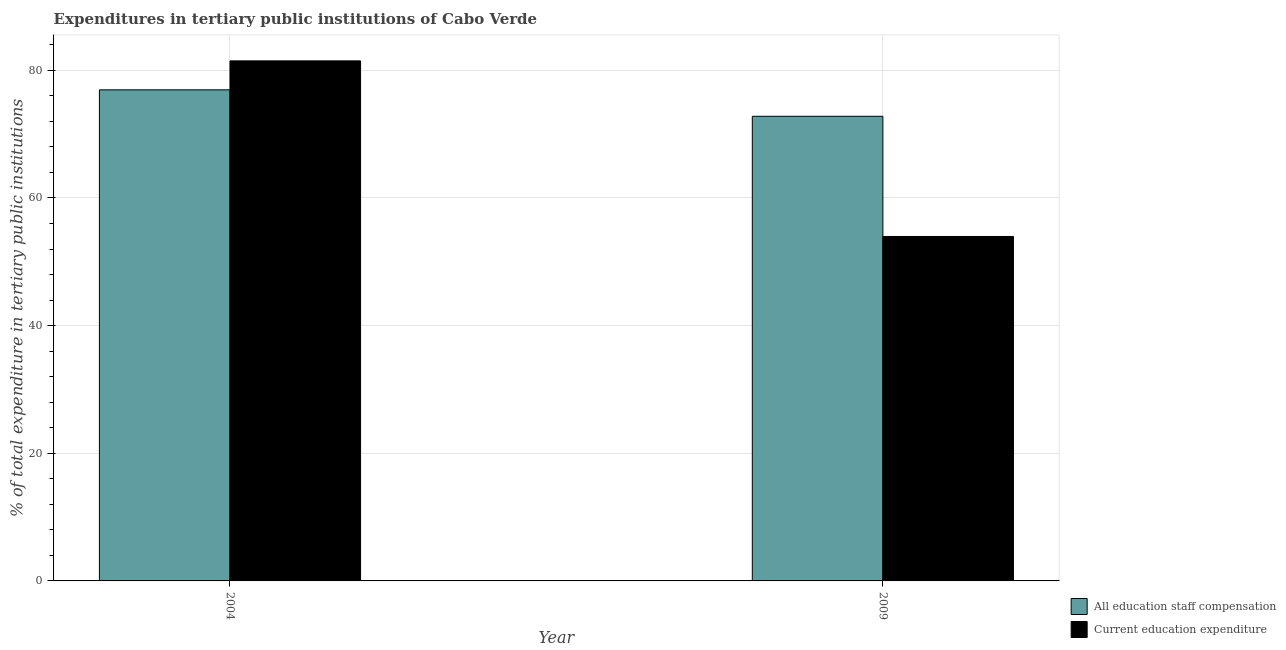What is the label of the 2nd group of bars from the left?
Provide a short and direct response. 2009. In how many cases, is the number of bars for a given year not equal to the number of legend labels?
Ensure brevity in your answer.  0. What is the expenditure in education in 2004?
Offer a very short reply. 81.48. Across all years, what is the maximum expenditure in staff compensation?
Your response must be concise. 76.94. Across all years, what is the minimum expenditure in staff compensation?
Offer a terse response. 72.8. What is the total expenditure in staff compensation in the graph?
Keep it short and to the point. 149.73. What is the difference between the expenditure in staff compensation in 2004 and that in 2009?
Offer a terse response. 4.14. What is the difference between the expenditure in staff compensation in 2004 and the expenditure in education in 2009?
Make the answer very short. 4.14. What is the average expenditure in education per year?
Offer a terse response. 67.72. In how many years, is the expenditure in education greater than 60 %?
Your answer should be compact. 1. What is the ratio of the expenditure in staff compensation in 2004 to that in 2009?
Your answer should be very brief. 1.06. In how many years, is the expenditure in staff compensation greater than the average expenditure in staff compensation taken over all years?
Provide a short and direct response. 1. What does the 1st bar from the left in 2009 represents?
Ensure brevity in your answer.  All education staff compensation. What does the 2nd bar from the right in 2004 represents?
Make the answer very short. All education staff compensation. Are all the bars in the graph horizontal?
Make the answer very short. No. What is the difference between two consecutive major ticks on the Y-axis?
Give a very brief answer. 20. Are the values on the major ticks of Y-axis written in scientific E-notation?
Offer a very short reply. No. Does the graph contain any zero values?
Give a very brief answer. No. Does the graph contain grids?
Ensure brevity in your answer.  Yes. How are the legend labels stacked?
Offer a terse response. Vertical. What is the title of the graph?
Ensure brevity in your answer.  Expenditures in tertiary public institutions of Cabo Verde. Does "Taxes on profits and capital gains" appear as one of the legend labels in the graph?
Keep it short and to the point. No. What is the label or title of the Y-axis?
Keep it short and to the point. % of total expenditure in tertiary public institutions. What is the % of total expenditure in tertiary public institutions of All education staff compensation in 2004?
Ensure brevity in your answer.  76.94. What is the % of total expenditure in tertiary public institutions in Current education expenditure in 2004?
Your response must be concise. 81.48. What is the % of total expenditure in tertiary public institutions in All education staff compensation in 2009?
Provide a succinct answer. 72.8. What is the % of total expenditure in tertiary public institutions in Current education expenditure in 2009?
Your answer should be very brief. 53.97. Across all years, what is the maximum % of total expenditure in tertiary public institutions of All education staff compensation?
Offer a very short reply. 76.94. Across all years, what is the maximum % of total expenditure in tertiary public institutions in Current education expenditure?
Your answer should be very brief. 81.48. Across all years, what is the minimum % of total expenditure in tertiary public institutions in All education staff compensation?
Give a very brief answer. 72.8. Across all years, what is the minimum % of total expenditure in tertiary public institutions of Current education expenditure?
Give a very brief answer. 53.97. What is the total % of total expenditure in tertiary public institutions of All education staff compensation in the graph?
Offer a terse response. 149.73. What is the total % of total expenditure in tertiary public institutions of Current education expenditure in the graph?
Give a very brief answer. 135.44. What is the difference between the % of total expenditure in tertiary public institutions of All education staff compensation in 2004 and that in 2009?
Your answer should be very brief. 4.14. What is the difference between the % of total expenditure in tertiary public institutions of Current education expenditure in 2004 and that in 2009?
Give a very brief answer. 27.51. What is the difference between the % of total expenditure in tertiary public institutions of All education staff compensation in 2004 and the % of total expenditure in tertiary public institutions of Current education expenditure in 2009?
Your answer should be compact. 22.97. What is the average % of total expenditure in tertiary public institutions in All education staff compensation per year?
Make the answer very short. 74.87. What is the average % of total expenditure in tertiary public institutions in Current education expenditure per year?
Your answer should be very brief. 67.72. In the year 2004, what is the difference between the % of total expenditure in tertiary public institutions of All education staff compensation and % of total expenditure in tertiary public institutions of Current education expenditure?
Offer a very short reply. -4.54. In the year 2009, what is the difference between the % of total expenditure in tertiary public institutions in All education staff compensation and % of total expenditure in tertiary public institutions in Current education expenditure?
Give a very brief answer. 18.83. What is the ratio of the % of total expenditure in tertiary public institutions of All education staff compensation in 2004 to that in 2009?
Provide a short and direct response. 1.06. What is the ratio of the % of total expenditure in tertiary public institutions of Current education expenditure in 2004 to that in 2009?
Ensure brevity in your answer.  1.51. What is the difference between the highest and the second highest % of total expenditure in tertiary public institutions of All education staff compensation?
Your answer should be compact. 4.14. What is the difference between the highest and the second highest % of total expenditure in tertiary public institutions of Current education expenditure?
Offer a terse response. 27.51. What is the difference between the highest and the lowest % of total expenditure in tertiary public institutions in All education staff compensation?
Your answer should be compact. 4.14. What is the difference between the highest and the lowest % of total expenditure in tertiary public institutions in Current education expenditure?
Offer a terse response. 27.51. 